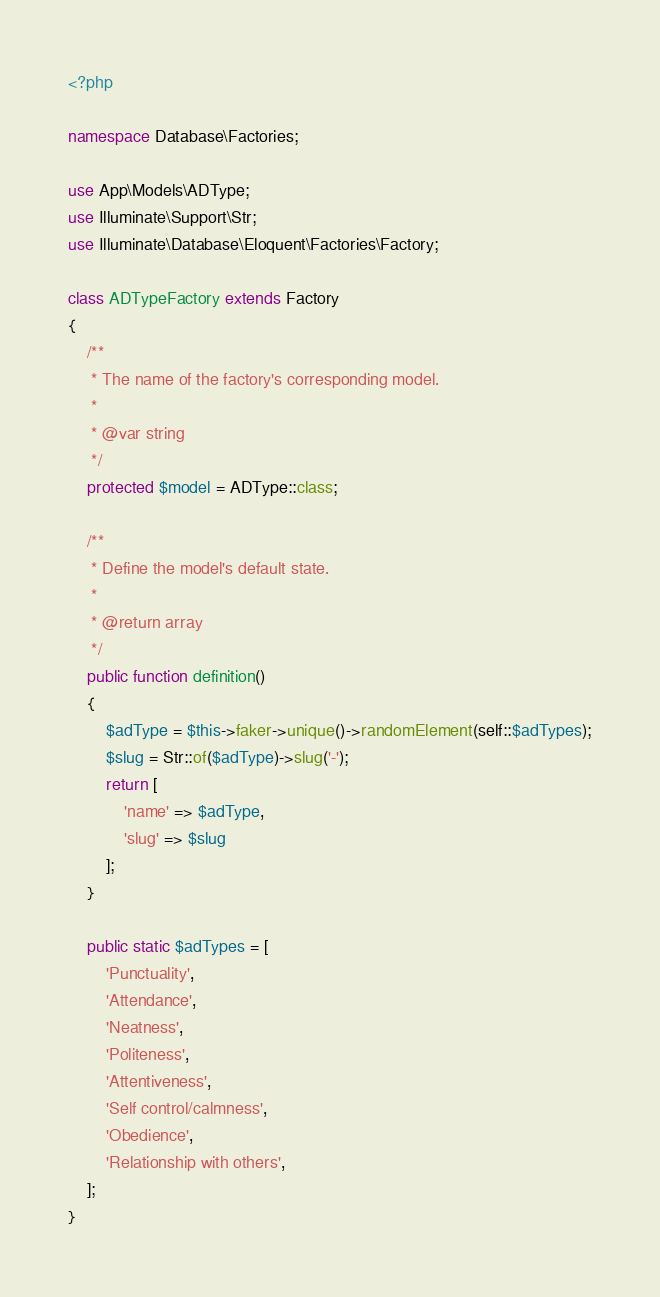<code> <loc_0><loc_0><loc_500><loc_500><_PHP_><?php

namespace Database\Factories;

use App\Models\ADType;
use Illuminate\Support\Str;
use Illuminate\Database\Eloquent\Factories\Factory;

class ADTypeFactory extends Factory
{
    /**
     * The name of the factory's corresponding model.
     *
     * @var string
     */
    protected $model = ADType::class;

    /**
     * Define the model's default state.
     *
     * @return array
     */
    public function definition()
    {
        $adType = $this->faker->unique()->randomElement(self::$adTypes);
        $slug = Str::of($adType)->slug('-');
        return [
            'name' => $adType,
            'slug' => $slug
        ];
    }

    public static $adTypes = [
        'Punctuality',
        'Attendance',
        'Neatness',
        'Politeness',
        'Attentiveness',
        'Self control/calmness',
        'Obedience',
        'Relationship with others',
    ];
}
</code> 